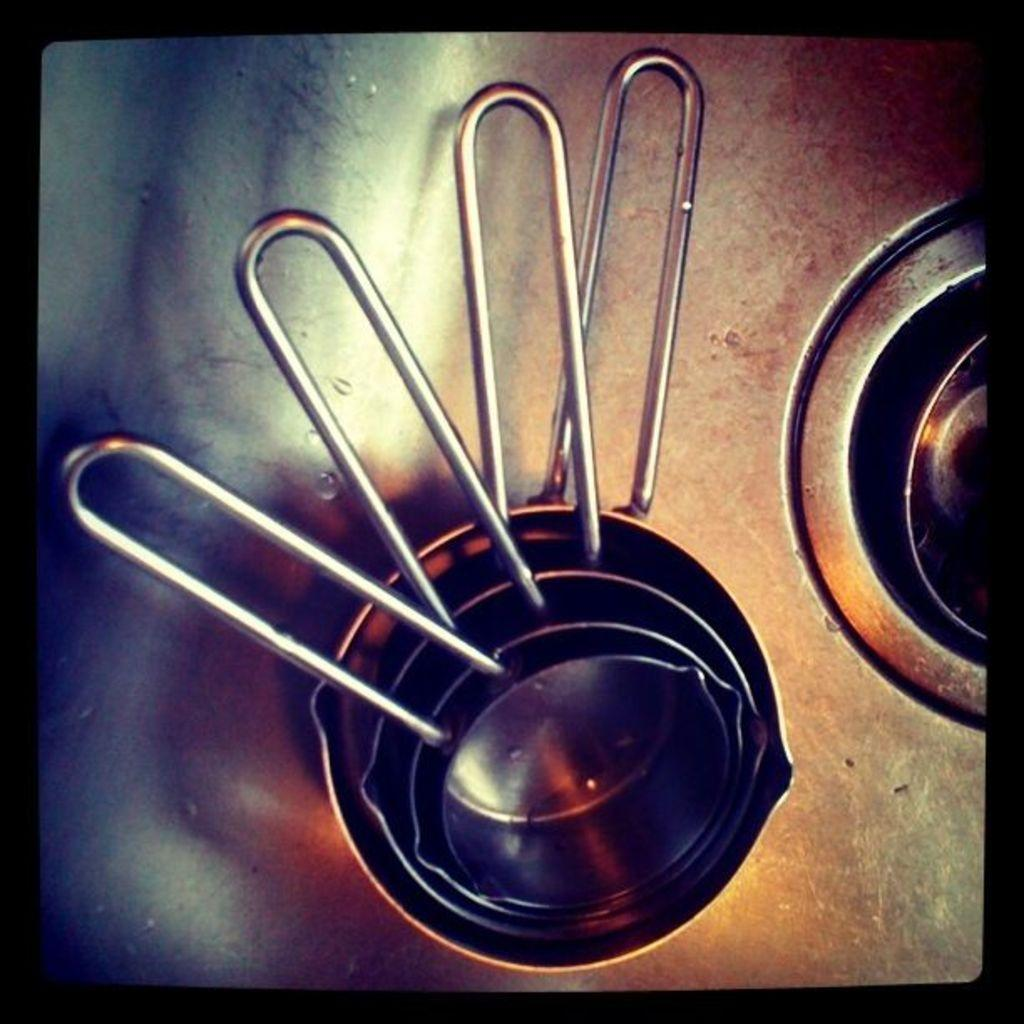What type of objects are present in the image? There are vessels in the image. What is the color of the vessels? The vessels are silver in color. What is the color of the surface on which the vessels are placed? The surface is also silver in color. What type of protest is taking place in the image? There is no protest present in the image; it only features silver vessels on a silver surface. 